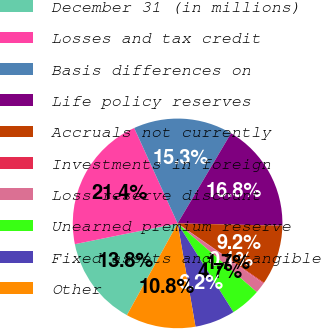<chart> <loc_0><loc_0><loc_500><loc_500><pie_chart><fcel>December 31 (in millions)<fcel>Losses and tax credit<fcel>Basis differences on<fcel>Life policy reserves<fcel>Accruals not currently<fcel>Investments in foreign<fcel>Loss reserve discount<fcel>Unearned premium reserve<fcel>Fixed assets and intangible<fcel>Other<nl><fcel>13.79%<fcel>21.38%<fcel>15.31%<fcel>16.83%<fcel>9.24%<fcel>0.13%<fcel>1.65%<fcel>4.69%<fcel>6.21%<fcel>10.76%<nl></chart> 